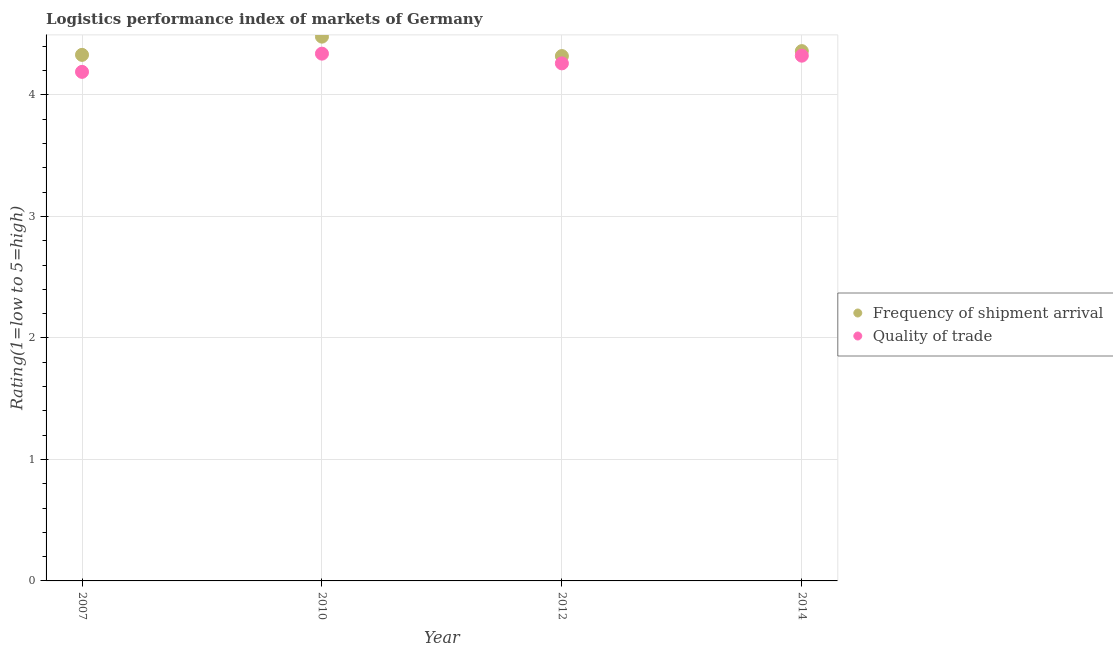How many different coloured dotlines are there?
Your answer should be very brief. 2. Is the number of dotlines equal to the number of legend labels?
Provide a short and direct response. Yes. What is the lpi of frequency of shipment arrival in 2012?
Give a very brief answer. 4.32. Across all years, what is the maximum lpi quality of trade?
Make the answer very short. 4.34. Across all years, what is the minimum lpi quality of trade?
Provide a succinct answer. 4.19. In which year was the lpi of frequency of shipment arrival minimum?
Ensure brevity in your answer.  2012. What is the total lpi quality of trade in the graph?
Your response must be concise. 17.11. What is the difference between the lpi of frequency of shipment arrival in 2007 and that in 2014?
Your response must be concise. -0.03. What is the difference between the lpi quality of trade in 2010 and the lpi of frequency of shipment arrival in 2012?
Provide a short and direct response. 0.02. What is the average lpi quality of trade per year?
Your answer should be very brief. 4.28. In the year 2010, what is the difference between the lpi quality of trade and lpi of frequency of shipment arrival?
Your response must be concise. -0.14. What is the ratio of the lpi of frequency of shipment arrival in 2007 to that in 2012?
Your answer should be compact. 1. What is the difference between the highest and the second highest lpi of frequency of shipment arrival?
Your response must be concise. 0.12. What is the difference between the highest and the lowest lpi quality of trade?
Your answer should be compact. 0.15. In how many years, is the lpi of frequency of shipment arrival greater than the average lpi of frequency of shipment arrival taken over all years?
Provide a short and direct response. 1. Is the lpi of frequency of shipment arrival strictly less than the lpi quality of trade over the years?
Ensure brevity in your answer.  No. How many dotlines are there?
Your answer should be compact. 2. What is the difference between two consecutive major ticks on the Y-axis?
Provide a succinct answer. 1. Does the graph contain any zero values?
Your answer should be very brief. No. Does the graph contain grids?
Offer a very short reply. Yes. Where does the legend appear in the graph?
Your response must be concise. Center right. How are the legend labels stacked?
Your answer should be very brief. Vertical. What is the title of the graph?
Give a very brief answer. Logistics performance index of markets of Germany. Does "External balance on goods" appear as one of the legend labels in the graph?
Offer a terse response. No. What is the label or title of the Y-axis?
Your response must be concise. Rating(1=low to 5=high). What is the Rating(1=low to 5=high) of Frequency of shipment arrival in 2007?
Ensure brevity in your answer.  4.33. What is the Rating(1=low to 5=high) of Quality of trade in 2007?
Ensure brevity in your answer.  4.19. What is the Rating(1=low to 5=high) of Frequency of shipment arrival in 2010?
Provide a succinct answer. 4.48. What is the Rating(1=low to 5=high) of Quality of trade in 2010?
Ensure brevity in your answer.  4.34. What is the Rating(1=low to 5=high) in Frequency of shipment arrival in 2012?
Your response must be concise. 4.32. What is the Rating(1=low to 5=high) of Quality of trade in 2012?
Make the answer very short. 4.26. What is the Rating(1=low to 5=high) of Frequency of shipment arrival in 2014?
Your answer should be very brief. 4.36. What is the Rating(1=low to 5=high) of Quality of trade in 2014?
Offer a terse response. 4.32. Across all years, what is the maximum Rating(1=low to 5=high) in Frequency of shipment arrival?
Provide a short and direct response. 4.48. Across all years, what is the maximum Rating(1=low to 5=high) in Quality of trade?
Your answer should be very brief. 4.34. Across all years, what is the minimum Rating(1=low to 5=high) of Frequency of shipment arrival?
Give a very brief answer. 4.32. Across all years, what is the minimum Rating(1=low to 5=high) of Quality of trade?
Your response must be concise. 4.19. What is the total Rating(1=low to 5=high) in Frequency of shipment arrival in the graph?
Offer a terse response. 17.49. What is the total Rating(1=low to 5=high) in Quality of trade in the graph?
Your answer should be very brief. 17.11. What is the difference between the Rating(1=low to 5=high) of Frequency of shipment arrival in 2007 and that in 2010?
Your answer should be very brief. -0.15. What is the difference between the Rating(1=low to 5=high) of Quality of trade in 2007 and that in 2010?
Make the answer very short. -0.15. What is the difference between the Rating(1=low to 5=high) of Frequency of shipment arrival in 2007 and that in 2012?
Give a very brief answer. 0.01. What is the difference between the Rating(1=low to 5=high) of Quality of trade in 2007 and that in 2012?
Make the answer very short. -0.07. What is the difference between the Rating(1=low to 5=high) in Frequency of shipment arrival in 2007 and that in 2014?
Offer a very short reply. -0.03. What is the difference between the Rating(1=low to 5=high) in Quality of trade in 2007 and that in 2014?
Offer a terse response. -0.13. What is the difference between the Rating(1=low to 5=high) in Frequency of shipment arrival in 2010 and that in 2012?
Make the answer very short. 0.16. What is the difference between the Rating(1=low to 5=high) of Quality of trade in 2010 and that in 2012?
Your answer should be compact. 0.08. What is the difference between the Rating(1=low to 5=high) of Frequency of shipment arrival in 2010 and that in 2014?
Your response must be concise. 0.12. What is the difference between the Rating(1=low to 5=high) in Quality of trade in 2010 and that in 2014?
Keep it short and to the point. 0.02. What is the difference between the Rating(1=low to 5=high) of Frequency of shipment arrival in 2012 and that in 2014?
Ensure brevity in your answer.  -0.04. What is the difference between the Rating(1=low to 5=high) of Quality of trade in 2012 and that in 2014?
Ensure brevity in your answer.  -0.06. What is the difference between the Rating(1=low to 5=high) of Frequency of shipment arrival in 2007 and the Rating(1=low to 5=high) of Quality of trade in 2010?
Provide a succinct answer. -0.01. What is the difference between the Rating(1=low to 5=high) of Frequency of shipment arrival in 2007 and the Rating(1=low to 5=high) of Quality of trade in 2012?
Offer a terse response. 0.07. What is the difference between the Rating(1=low to 5=high) in Frequency of shipment arrival in 2007 and the Rating(1=low to 5=high) in Quality of trade in 2014?
Give a very brief answer. 0.01. What is the difference between the Rating(1=low to 5=high) of Frequency of shipment arrival in 2010 and the Rating(1=low to 5=high) of Quality of trade in 2012?
Provide a short and direct response. 0.22. What is the difference between the Rating(1=low to 5=high) in Frequency of shipment arrival in 2010 and the Rating(1=low to 5=high) in Quality of trade in 2014?
Make the answer very short. 0.16. What is the difference between the Rating(1=low to 5=high) of Frequency of shipment arrival in 2012 and the Rating(1=low to 5=high) of Quality of trade in 2014?
Ensure brevity in your answer.  -0. What is the average Rating(1=low to 5=high) of Frequency of shipment arrival per year?
Give a very brief answer. 4.37. What is the average Rating(1=low to 5=high) of Quality of trade per year?
Offer a terse response. 4.28. In the year 2007, what is the difference between the Rating(1=low to 5=high) of Frequency of shipment arrival and Rating(1=low to 5=high) of Quality of trade?
Provide a succinct answer. 0.14. In the year 2010, what is the difference between the Rating(1=low to 5=high) of Frequency of shipment arrival and Rating(1=low to 5=high) of Quality of trade?
Offer a terse response. 0.14. In the year 2014, what is the difference between the Rating(1=low to 5=high) in Frequency of shipment arrival and Rating(1=low to 5=high) in Quality of trade?
Offer a terse response. 0.04. What is the ratio of the Rating(1=low to 5=high) in Frequency of shipment arrival in 2007 to that in 2010?
Provide a succinct answer. 0.97. What is the ratio of the Rating(1=low to 5=high) of Quality of trade in 2007 to that in 2010?
Give a very brief answer. 0.97. What is the ratio of the Rating(1=low to 5=high) of Frequency of shipment arrival in 2007 to that in 2012?
Your response must be concise. 1. What is the ratio of the Rating(1=low to 5=high) in Quality of trade in 2007 to that in 2012?
Give a very brief answer. 0.98. What is the ratio of the Rating(1=low to 5=high) of Quality of trade in 2007 to that in 2014?
Provide a succinct answer. 0.97. What is the ratio of the Rating(1=low to 5=high) in Frequency of shipment arrival in 2010 to that in 2012?
Your response must be concise. 1.04. What is the ratio of the Rating(1=low to 5=high) in Quality of trade in 2010 to that in 2012?
Give a very brief answer. 1.02. What is the ratio of the Rating(1=low to 5=high) of Frequency of shipment arrival in 2010 to that in 2014?
Offer a terse response. 1.03. What is the ratio of the Rating(1=low to 5=high) in Quality of trade in 2010 to that in 2014?
Your answer should be very brief. 1. What is the ratio of the Rating(1=low to 5=high) in Frequency of shipment arrival in 2012 to that in 2014?
Offer a terse response. 0.99. What is the ratio of the Rating(1=low to 5=high) of Quality of trade in 2012 to that in 2014?
Your answer should be compact. 0.99. What is the difference between the highest and the second highest Rating(1=low to 5=high) of Frequency of shipment arrival?
Your answer should be compact. 0.12. What is the difference between the highest and the second highest Rating(1=low to 5=high) in Quality of trade?
Give a very brief answer. 0.02. What is the difference between the highest and the lowest Rating(1=low to 5=high) in Frequency of shipment arrival?
Your answer should be compact. 0.16. 